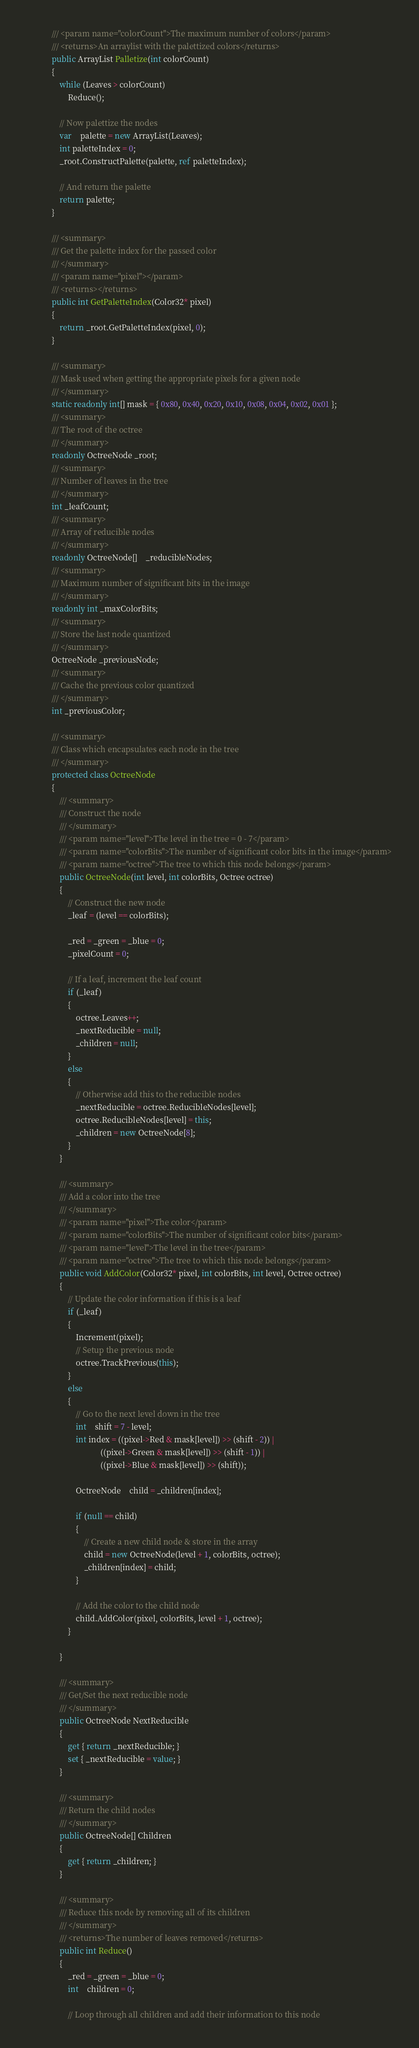Convert code to text. <code><loc_0><loc_0><loc_500><loc_500><_C#_>			/// <param name="colorCount">The maximum number of colors</param>
			/// <returns>An arraylist with the palettized colors</returns>
			public ArrayList Palletize(int colorCount)
			{
				while (Leaves > colorCount)
					Reduce();

				// Now palettize the nodes
				var	palette = new ArrayList(Leaves);
				int paletteIndex = 0;
				_root.ConstructPalette(palette, ref paletteIndex);

				// And return the palette
				return palette;
			}

			/// <summary>
			/// Get the palette index for the passed color
			/// </summary>
			/// <param name="pixel"></param>
			/// <returns></returns>
			public int GetPaletteIndex(Color32* pixel)
			{
				return _root.GetPaletteIndex(pixel, 0);
			}

			/// <summary>
			/// Mask used when getting the appropriate pixels for a given node
			/// </summary>
			static readonly int[] mask = { 0x80, 0x40, 0x20, 0x10, 0x08, 0x04, 0x02, 0x01 };
			/// <summary>
			/// The root of the octree
			/// </summary>
			readonly OctreeNode _root;
			/// <summary>
			/// Number of leaves in the tree
			/// </summary>
			int _leafCount;
			/// <summary>
			/// Array of reducible nodes
			/// </summary>
			readonly OctreeNode[]	_reducibleNodes;
			/// <summary>
			/// Maximum number of significant bits in the image
			/// </summary>
			readonly int _maxColorBits;
			/// <summary>
			/// Store the last node quantized
			/// </summary>
			OctreeNode _previousNode;
			/// <summary>
			/// Cache the previous color quantized
			/// </summary>
			int _previousColor;

			/// <summary>
			/// Class which encapsulates each node in the tree
			/// </summary>
			protected class OctreeNode
			{
				/// <summary>
				/// Construct the node
				/// </summary>
				/// <param name="level">The level in the tree = 0 - 7</param>
				/// <param name="colorBits">The number of significant color bits in the image</param>
				/// <param name="octree">The tree to which this node belongs</param>
				public OctreeNode(int level, int colorBits, Octree octree)
				{
					// Construct the new node
					_leaf = (level == colorBits);

					_red = _green = _blue = 0;
					_pixelCount = 0;

					// If a leaf, increment the leaf count
					if (_leaf)
					{
						octree.Leaves++;
						_nextReducible = null;
						_children = null; 
					}
					else
					{
						// Otherwise add this to the reducible nodes
						_nextReducible = octree.ReducibleNodes[level];
						octree.ReducibleNodes[level] = this;
						_children = new OctreeNode[8];
					}
				}

				/// <summary>
				/// Add a color into the tree
				/// </summary>
				/// <param name="pixel">The color</param>
				/// <param name="colorBits">The number of significant color bits</param>
				/// <param name="level">The level in the tree</param>
				/// <param name="octree">The tree to which this node belongs</param>
				public void AddColor(Color32* pixel, int colorBits, int level, Octree octree)
				{
					// Update the color information if this is a leaf
					if (_leaf)
					{
						Increment(pixel);
						// Setup the previous node
						octree.TrackPrevious(this);
					}
					else
					{
						// Go to the next level down in the tree
						int	shift = 7 - level;
						int index = ((pixel->Red & mask[level]) >> (shift - 2)) |
						            ((pixel->Green & mask[level]) >> (shift - 1)) |
						            ((pixel->Blue & mask[level]) >> (shift));

						OctreeNode	child = _children[index];

						if (null == child)
						{
							// Create a new child node & store in the array
							child = new OctreeNode(level + 1, colorBits, octree); 
							_children[index] = child;
						}

						// Add the color to the child node
						child.AddColor(pixel, colorBits, level + 1, octree);
					}

				}

				/// <summary>
				/// Get/Set the next reducible node
				/// </summary>
				public OctreeNode NextReducible
				{
					get { return _nextReducible; }
					set { _nextReducible = value; }
				}

				/// <summary>
				/// Return the child nodes
				/// </summary>
				public OctreeNode[] Children
				{
					get { return _children; }
				}

				/// <summary>
				/// Reduce this node by removing all of its children
				/// </summary>
				/// <returns>The number of leaves removed</returns>
				public int Reduce()
				{
					_red = _green = _blue = 0;
					int	children = 0;

					// Loop through all children and add their information to this node</code> 